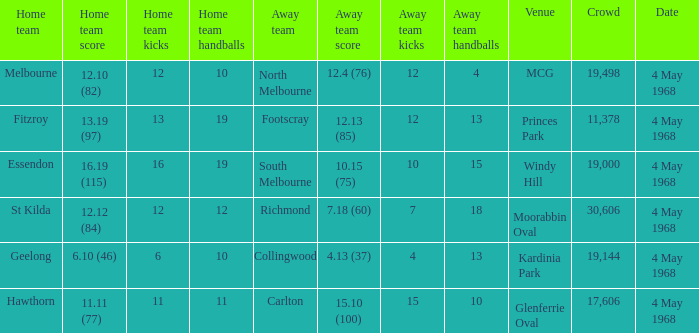What home team played at MCG? North Melbourne. 